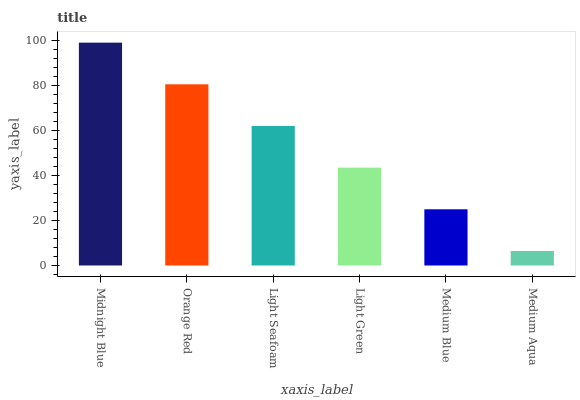Is Medium Aqua the minimum?
Answer yes or no. Yes. Is Midnight Blue the maximum?
Answer yes or no. Yes. Is Orange Red the minimum?
Answer yes or no. No. Is Orange Red the maximum?
Answer yes or no. No. Is Midnight Blue greater than Orange Red?
Answer yes or no. Yes. Is Orange Red less than Midnight Blue?
Answer yes or no. Yes. Is Orange Red greater than Midnight Blue?
Answer yes or no. No. Is Midnight Blue less than Orange Red?
Answer yes or no. No. Is Light Seafoam the high median?
Answer yes or no. Yes. Is Light Green the low median?
Answer yes or no. Yes. Is Midnight Blue the high median?
Answer yes or no. No. Is Midnight Blue the low median?
Answer yes or no. No. 